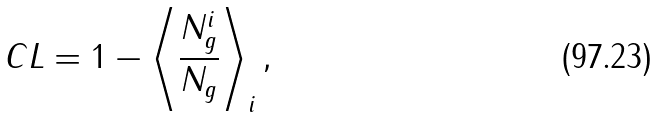Convert formula to latex. <formula><loc_0><loc_0><loc_500><loc_500>C L = 1 - \left \langle \frac { N _ { g } ^ { i } } { N _ { g } } \right \rangle _ { i } ,</formula> 